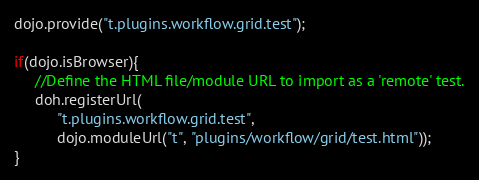<code> <loc_0><loc_0><loc_500><loc_500><_JavaScript_>dojo.provide("t.plugins.workflow.grid.test");

if(dojo.isBrowser){
     //Define the HTML file/module URL to import as a 'remote' test.
     doh.registerUrl(
          "t.plugins.workflow.grid.test", 
          dojo.moduleUrl("t", "plugins/workflow/grid/test.html"));
}
</code> 